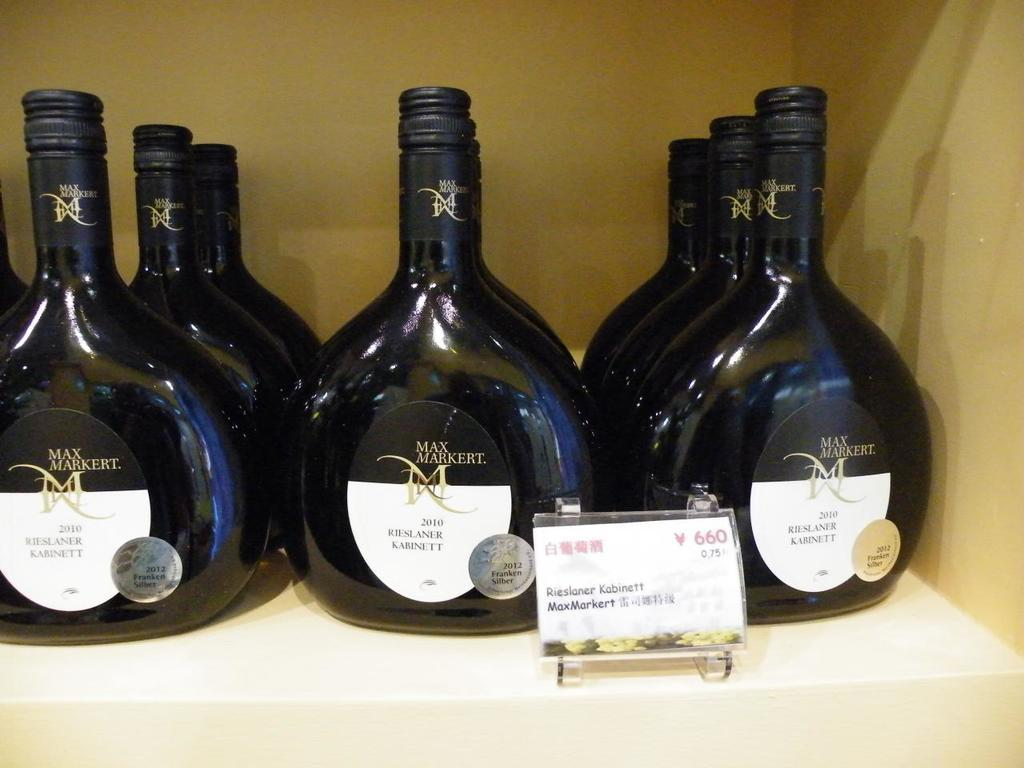<image>
Share a concise interpretation of the image provided. A Shelf containing Max Markert wine is on display. 